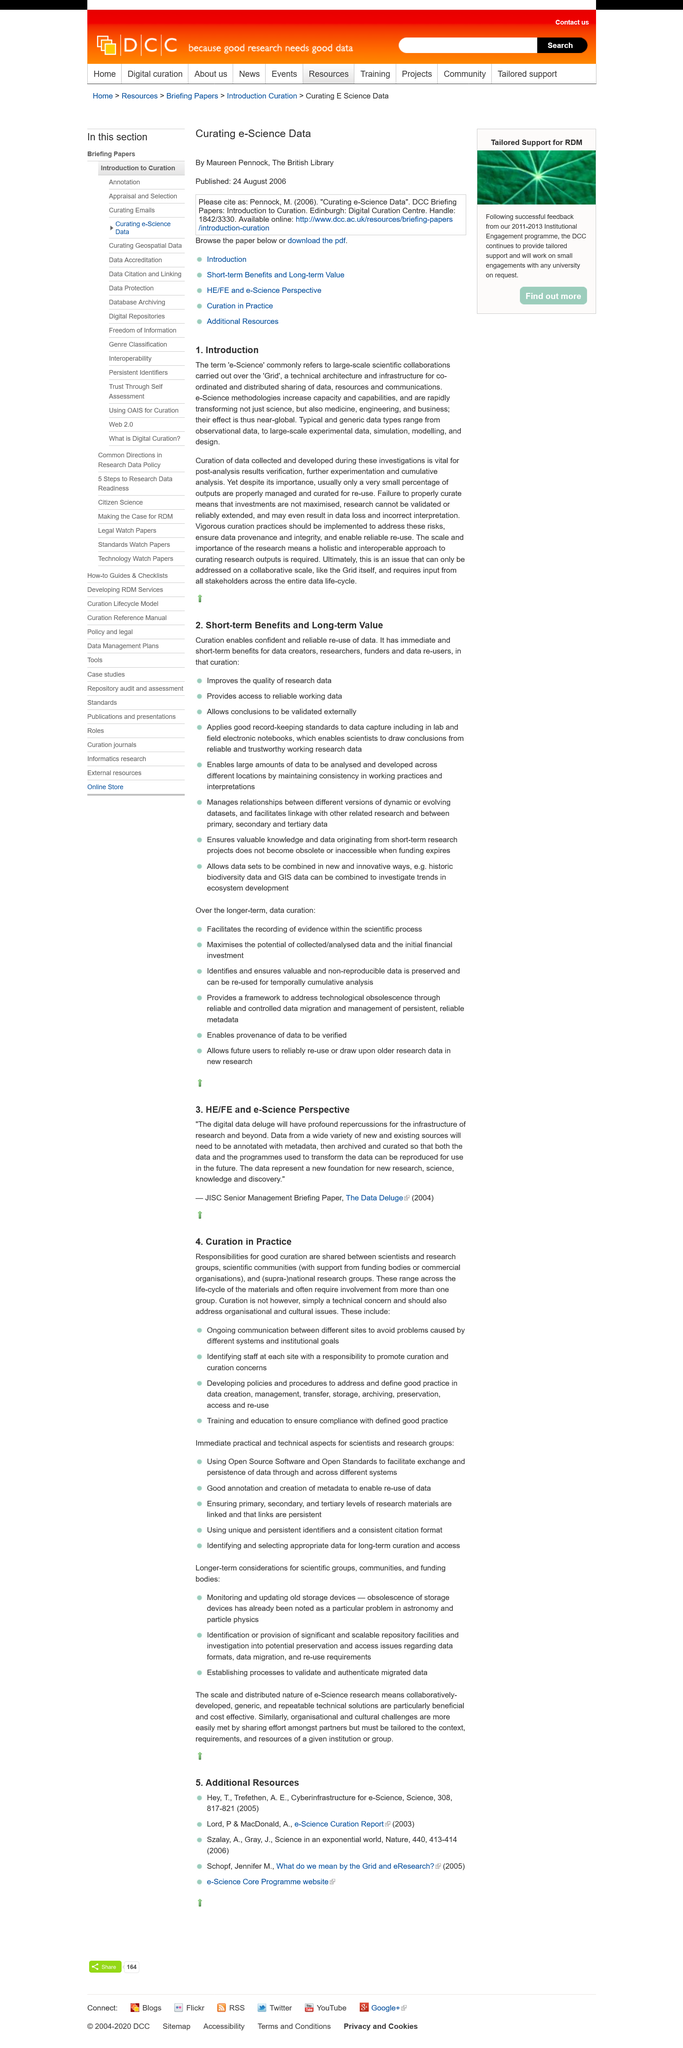Draw attention to some important aspects in this diagram. The paper was published in the year 2004. E-science methodologies increase the capacity and capabilities of scientists to conduct research more effectively and efficiently, thereby enabling them to produce higher-quality scientific results. Yes, it is a part of the introduction that the term "e-Science" refers to large-scale scientific collaborations. To avoid problems caused by different systems and institutional goals, ongoing communication between different sites is essential. The data will require metadata annotations in order to be effectively utilized. 